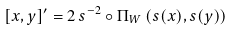<formula> <loc_0><loc_0><loc_500><loc_500>[ x , y ] ^ { \prime } = 2 \, s ^ { - 2 } \circ \Pi _ { W } \left ( s ( x ) , s ( y ) \right )</formula> 